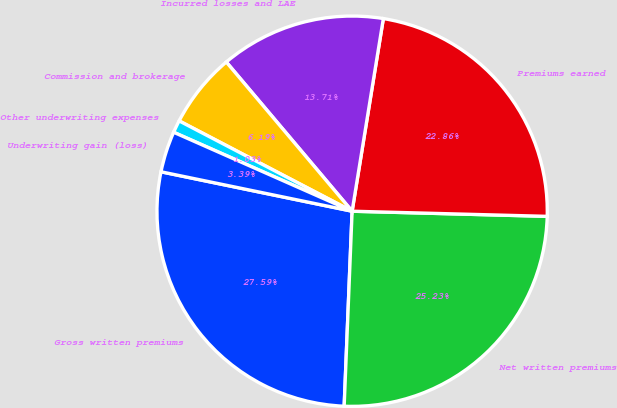<chart> <loc_0><loc_0><loc_500><loc_500><pie_chart><fcel>Gross written premiums<fcel>Net written premiums<fcel>Premiums earned<fcel>Incurred losses and LAE<fcel>Commission and brokerage<fcel>Other underwriting expenses<fcel>Underwriting gain (loss)<nl><fcel>27.59%<fcel>25.23%<fcel>22.86%<fcel>13.71%<fcel>6.19%<fcel>1.03%<fcel>3.39%<nl></chart> 